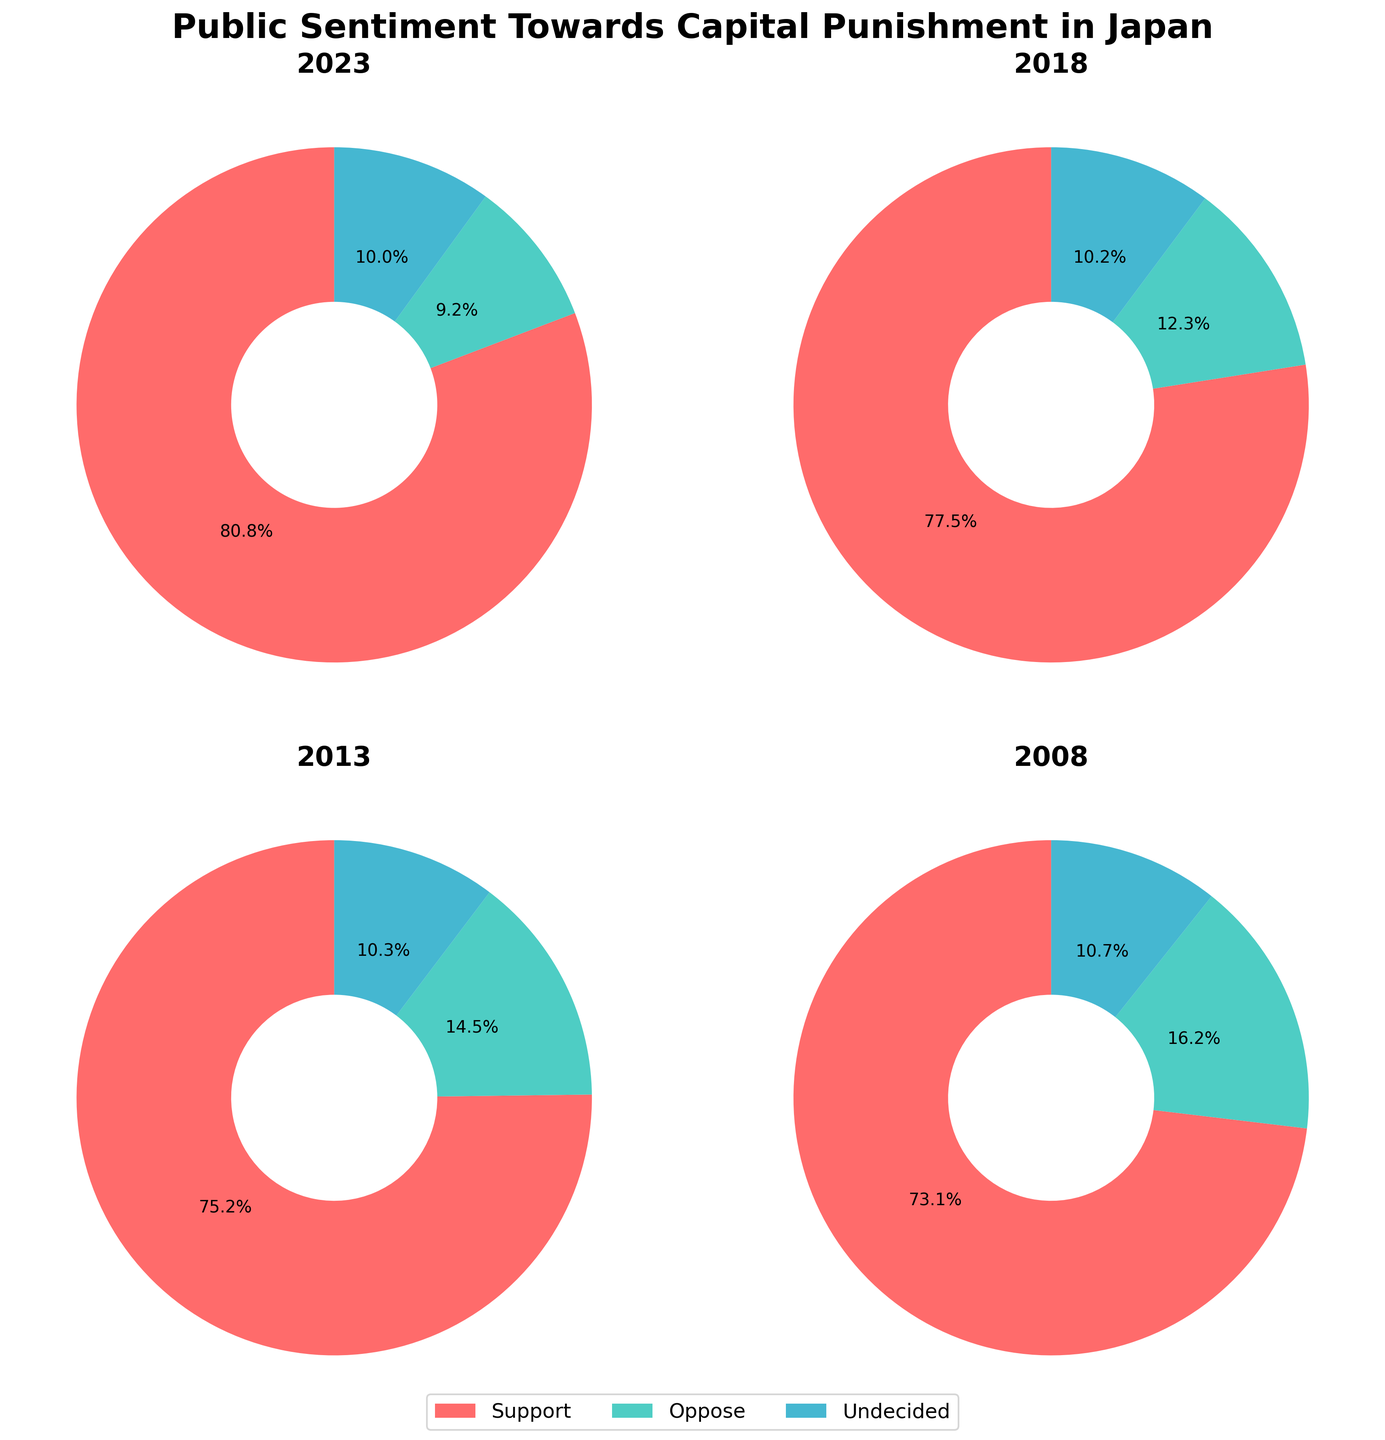What is the title of the figure? The title of the figure is displayed at the top of the plot. It reads "Public Sentiment Towards Capital Punishment in Japan".
Answer: Public Sentiment Towards Capital Punishment in Japan Which category had the highest percentage in 2023? By looking at the pie chart for the year 2023, the largest segment is labeled "Support", indicating it has the highest percentage.
Answer: Support What is the percentage of people who were undecided in 2008? In the pie chart for the year 2008, the segment labeled "Undecided" shows that it is 10.7%.
Answer: 10.7% How did the percentage of people opposed to capital punishment change from 2013 to 2018? In 2013, the percentage of people opposed to capital punishment was 14.5%, and in 2018, it was 12.3%. The change is calculated as 14.5% - 12.3% = 2.2% decrease.
Answer: 2.2% decrease Which year had the lowest percentage of opposition to capital punishment? By comparing the pie charts for all years, the year with the smallest "Oppose" segment is 2023, with 9.2%.
Answer: 2023 What are the three categories represented in the pie charts? Each pie chart has three segments with labels. The categories are "Support", "Oppose", and "Undecided".
Answer: Support, Oppose, Undecided How did the support for capital punishment change from 2008 to 2023? From 2008 to 2023, the support increased from 73.1% to 80.8%. The change is calculated as 80.8% - 73.1% = 7.7% increase.
Answer: 7.7% increase Calculate the sum of the "Undecided" percentages for all the years shown. The "Undecided" percentages for each year are: 2023: 10.0%, 2018: 10.2%, 2013: 10.3%, 2008: 10.7%. Summing these up results in 10.0% + 10.2% + 10.3% + 10.7% = 41.2%.
Answer: 41.2% Which category color represents opposition to capital punishment? The color representing the "Oppose" category can be identified by looking at the legend, which shows that "Oppose" is in green.
Answer: Green 